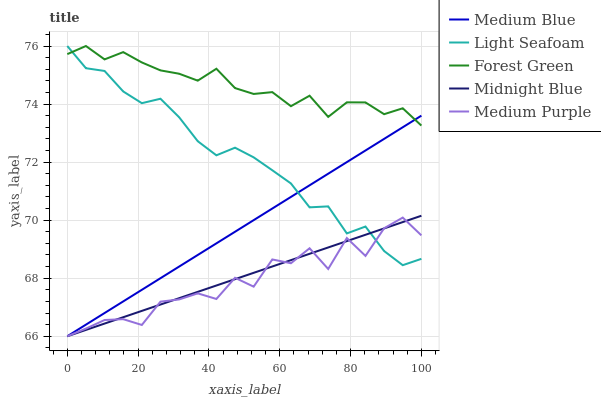Does Medium Purple have the minimum area under the curve?
Answer yes or no. Yes. Does Forest Green have the maximum area under the curve?
Answer yes or no. Yes. Does Light Seafoam have the minimum area under the curve?
Answer yes or no. No. Does Light Seafoam have the maximum area under the curve?
Answer yes or no. No. Is Medium Blue the smoothest?
Answer yes or no. Yes. Is Medium Purple the roughest?
Answer yes or no. Yes. Is Forest Green the smoothest?
Answer yes or no. No. Is Forest Green the roughest?
Answer yes or no. No. Does Medium Purple have the lowest value?
Answer yes or no. Yes. Does Light Seafoam have the lowest value?
Answer yes or no. No. Does Light Seafoam have the highest value?
Answer yes or no. Yes. Does Medium Blue have the highest value?
Answer yes or no. No. Is Medium Purple less than Forest Green?
Answer yes or no. Yes. Is Forest Green greater than Midnight Blue?
Answer yes or no. Yes. Does Medium Blue intersect Midnight Blue?
Answer yes or no. Yes. Is Medium Blue less than Midnight Blue?
Answer yes or no. No. Is Medium Blue greater than Midnight Blue?
Answer yes or no. No. Does Medium Purple intersect Forest Green?
Answer yes or no. No. 